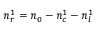<formula> <loc_0><loc_0><loc_500><loc_500>n _ { r } ^ { 1 } = n _ { 0 } - n _ { c } ^ { 1 } - n _ { l } ^ { 1 }</formula> 